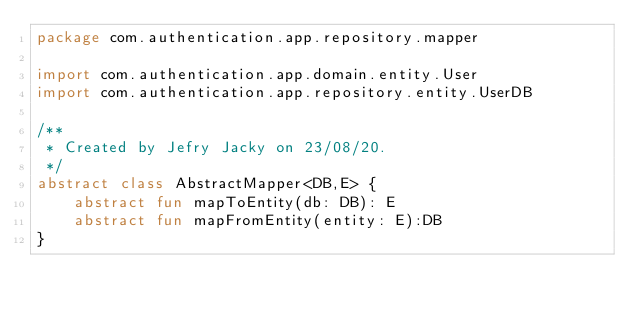Convert code to text. <code><loc_0><loc_0><loc_500><loc_500><_Kotlin_>package com.authentication.app.repository.mapper

import com.authentication.app.domain.entity.User
import com.authentication.app.repository.entity.UserDB

/**
 * Created by Jefry Jacky on 23/08/20.
 */
abstract class AbstractMapper<DB,E> {
    abstract fun mapToEntity(db: DB): E
    abstract fun mapFromEntity(entity: E):DB
}</code> 